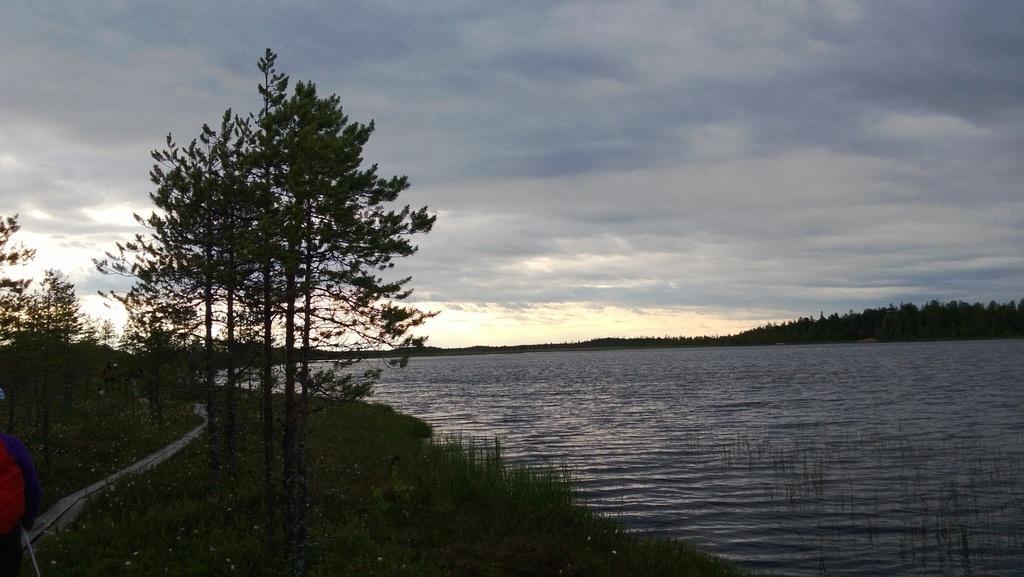Describe this image in one or two sentences. In this image we can see few trees, plants, water and the sky with clouds in the background. 